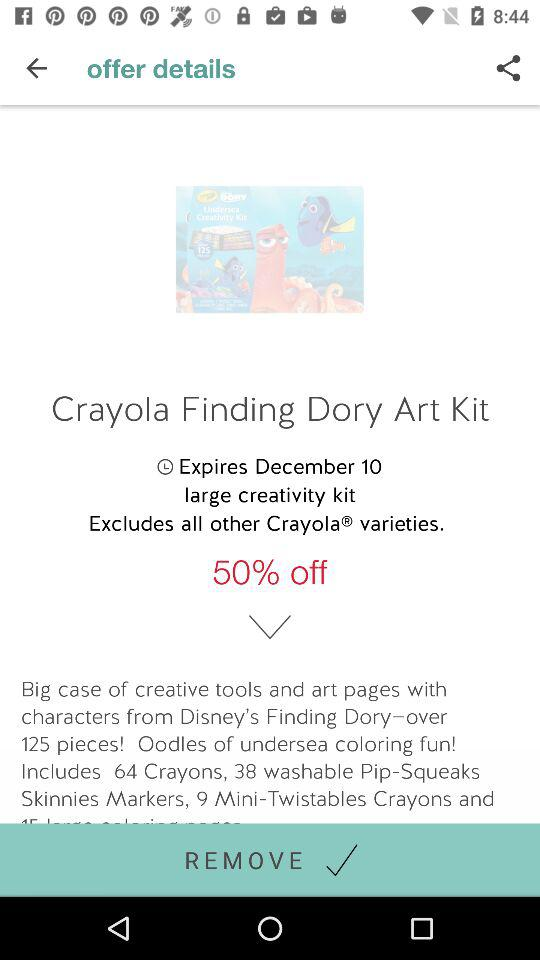How many crayons are in the Crayola Finding Dory Art Kit?
Answer the question using a single word or phrase. 64 